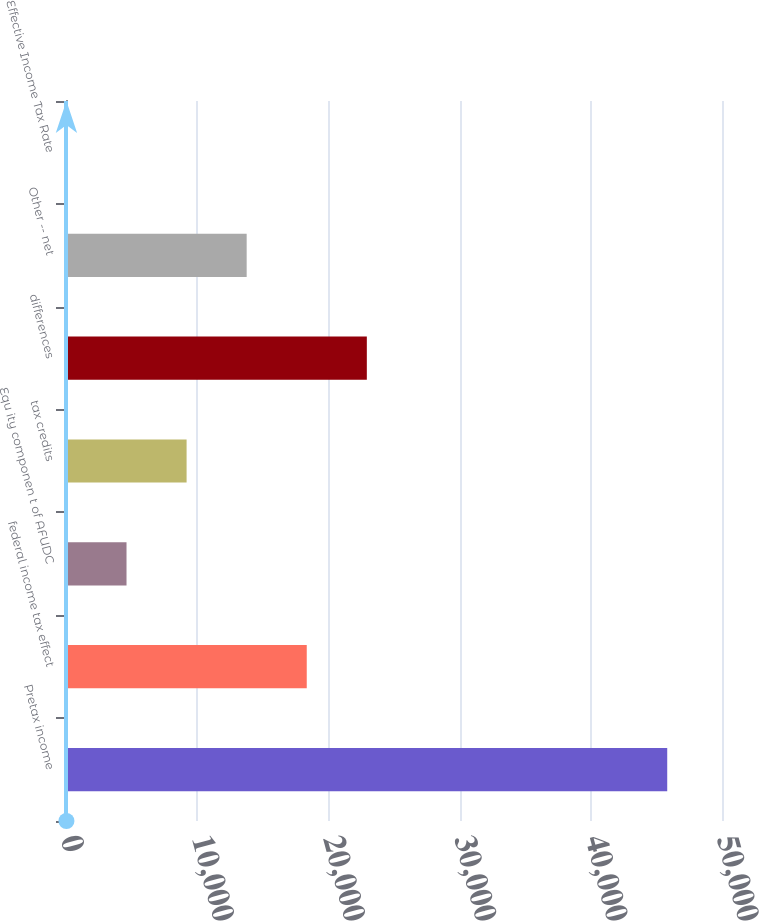Convert chart. <chart><loc_0><loc_0><loc_500><loc_500><bar_chart><fcel>Pretax income<fcel>federal income tax effect<fcel>Equ ity componen t of AFUDC<fcel>tax credits<fcel>differences<fcel>Other -- net<fcel>Effective Income Tax Rate<nl><fcel>45825<fcel>18350.1<fcel>4612.65<fcel>9191.8<fcel>22929.2<fcel>13771<fcel>33.5<nl></chart> 